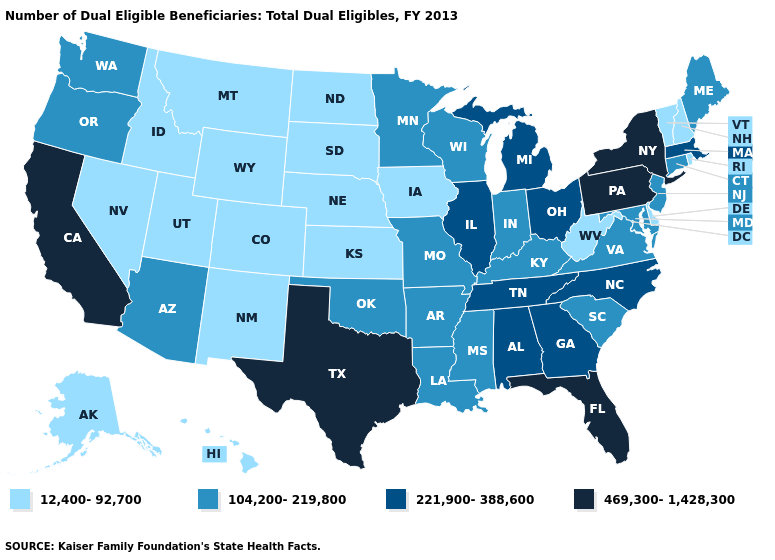Does Delaware have the lowest value in the South?
Concise answer only. Yes. Does the first symbol in the legend represent the smallest category?
Concise answer only. Yes. What is the lowest value in the South?
Give a very brief answer. 12,400-92,700. Does Pennsylvania have the highest value in the Northeast?
Keep it brief. Yes. Among the states that border Alabama , which have the lowest value?
Concise answer only. Mississippi. Name the states that have a value in the range 104,200-219,800?
Write a very short answer. Arizona, Arkansas, Connecticut, Indiana, Kentucky, Louisiana, Maine, Maryland, Minnesota, Mississippi, Missouri, New Jersey, Oklahoma, Oregon, South Carolina, Virginia, Washington, Wisconsin. Does Rhode Island have the same value as Wisconsin?
Keep it brief. No. What is the value of Hawaii?
Be succinct. 12,400-92,700. Does Pennsylvania have the highest value in the Northeast?
Concise answer only. Yes. Which states have the lowest value in the USA?
Answer briefly. Alaska, Colorado, Delaware, Hawaii, Idaho, Iowa, Kansas, Montana, Nebraska, Nevada, New Hampshire, New Mexico, North Dakota, Rhode Island, South Dakota, Utah, Vermont, West Virginia, Wyoming. What is the highest value in states that border South Carolina?
Be succinct. 221,900-388,600. What is the value of New Mexico?
Give a very brief answer. 12,400-92,700. Name the states that have a value in the range 469,300-1,428,300?
Concise answer only. California, Florida, New York, Pennsylvania, Texas. Among the states that border New Hampshire , which have the lowest value?
Be succinct. Vermont. Name the states that have a value in the range 469,300-1,428,300?
Quick response, please. California, Florida, New York, Pennsylvania, Texas. 